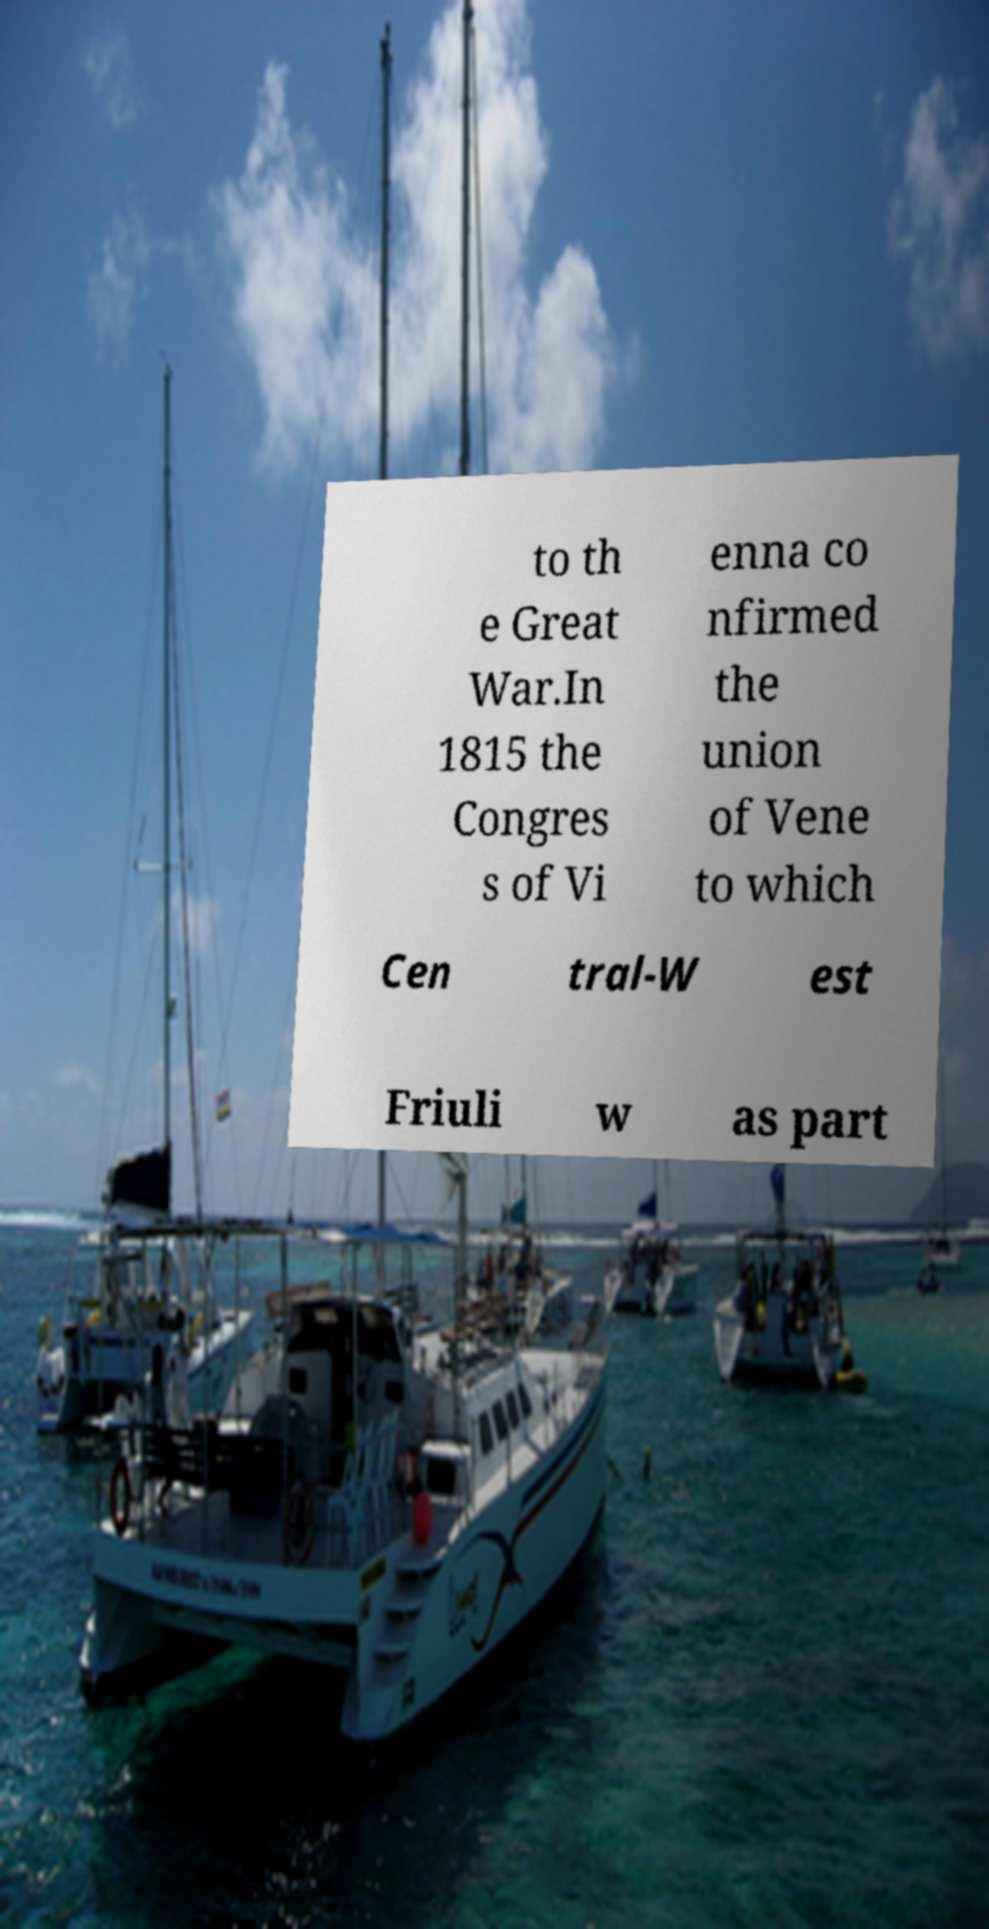Could you assist in decoding the text presented in this image and type it out clearly? to th e Great War.In 1815 the Congres s of Vi enna co nfirmed the union of Vene to which Cen tral-W est Friuli w as part 